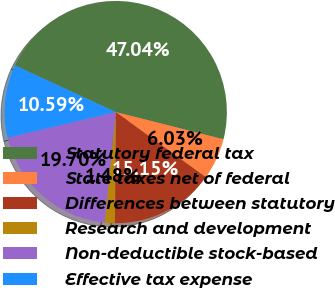Convert chart to OTSL. <chart><loc_0><loc_0><loc_500><loc_500><pie_chart><fcel>Statutory federal tax<fcel>State taxes net of federal<fcel>Differences between statutory<fcel>Research and development<fcel>Non-deductible stock-based<fcel>Effective tax expense<nl><fcel>47.04%<fcel>6.03%<fcel>15.15%<fcel>1.48%<fcel>19.7%<fcel>10.59%<nl></chart> 